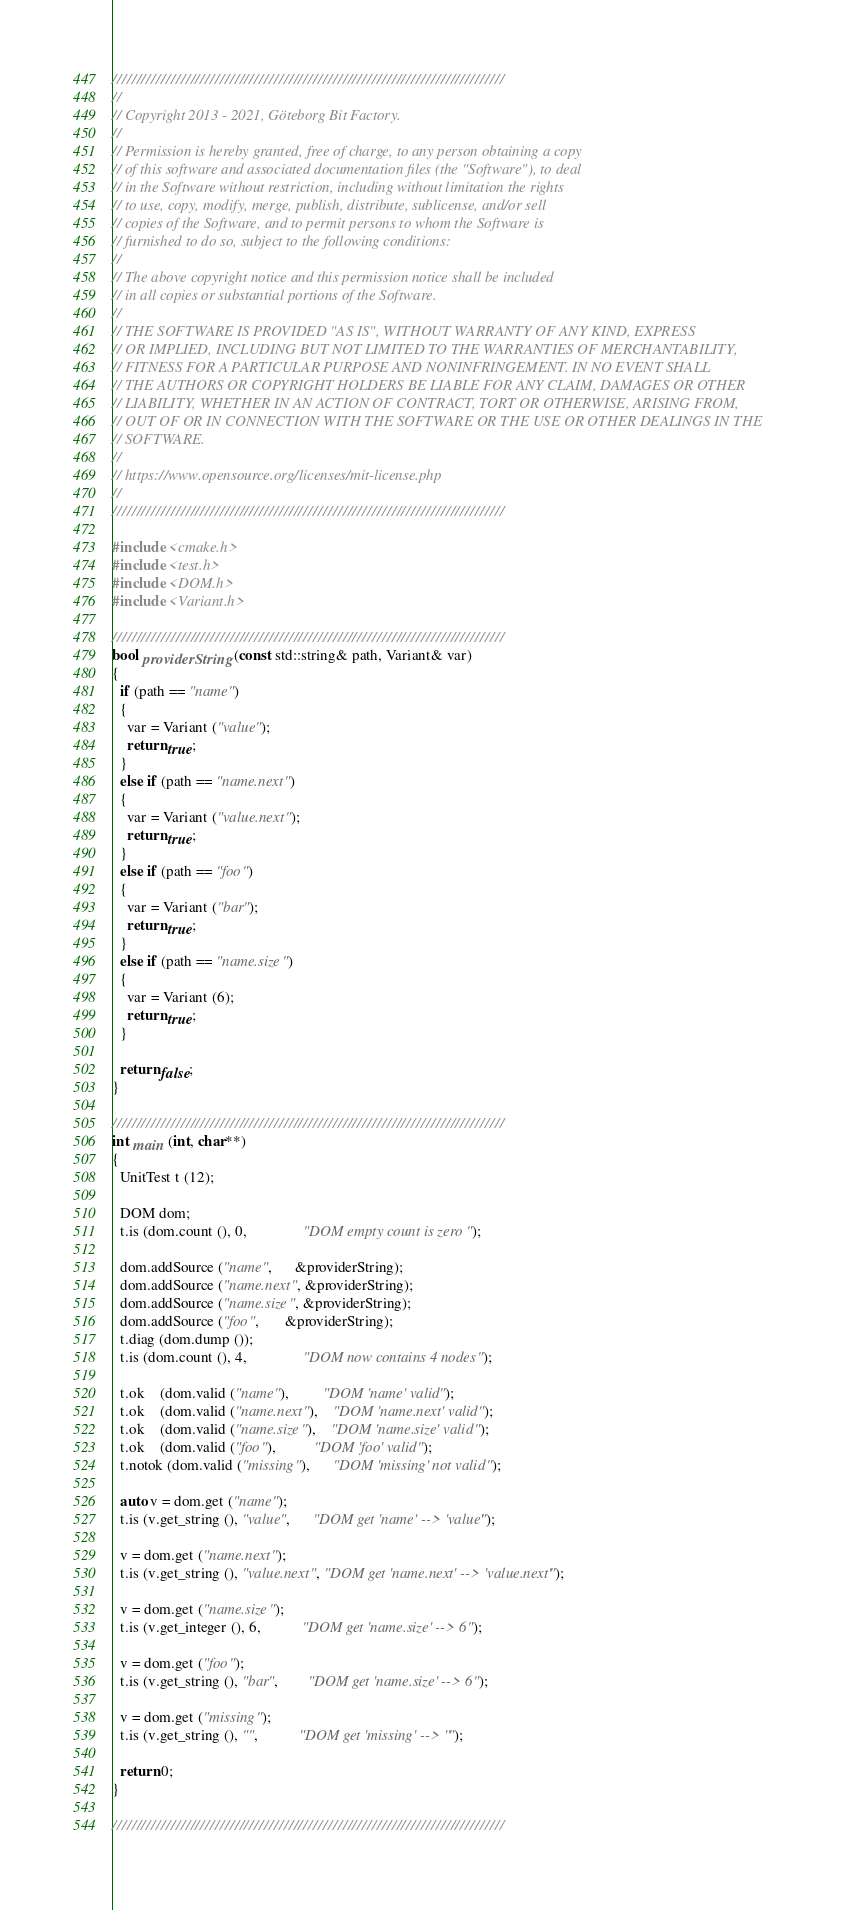Convert code to text. <code><loc_0><loc_0><loc_500><loc_500><_C++_>////////////////////////////////////////////////////////////////////////////////
//
// Copyright 2013 - 2021, Göteborg Bit Factory.
//
// Permission is hereby granted, free of charge, to any person obtaining a copy
// of this software and associated documentation files (the "Software"), to deal
// in the Software without restriction, including without limitation the rights
// to use, copy, modify, merge, publish, distribute, sublicense, and/or sell
// copies of the Software, and to permit persons to whom the Software is
// furnished to do so, subject to the following conditions:
//
// The above copyright notice and this permission notice shall be included
// in all copies or substantial portions of the Software.
//
// THE SOFTWARE IS PROVIDED "AS IS", WITHOUT WARRANTY OF ANY KIND, EXPRESS
// OR IMPLIED, INCLUDING BUT NOT LIMITED TO THE WARRANTIES OF MERCHANTABILITY,
// FITNESS FOR A PARTICULAR PURPOSE AND NONINFRINGEMENT. IN NO EVENT SHALL
// THE AUTHORS OR COPYRIGHT HOLDERS BE LIABLE FOR ANY CLAIM, DAMAGES OR OTHER
// LIABILITY, WHETHER IN AN ACTION OF CONTRACT, TORT OR OTHERWISE, ARISING FROM,
// OUT OF OR IN CONNECTION WITH THE SOFTWARE OR THE USE OR OTHER DEALINGS IN THE
// SOFTWARE.
//
// https://www.opensource.org/licenses/mit-license.php
//
////////////////////////////////////////////////////////////////////////////////

#include <cmake.h>
#include <test.h>
#include <DOM.h>
#include <Variant.h>

////////////////////////////////////////////////////////////////////////////////
bool providerString (const std::string& path, Variant& var)
{
  if (path == "name")
  {
    var = Variant ("value");
    return true;
  }
  else if (path == "name.next")
  {
    var = Variant ("value.next");
    return true;
  }
  else if (path == "foo")
  {
    var = Variant ("bar");
    return true;
  }
  else if (path == "name.size")
  {
    var = Variant (6);
    return true;
  }

  return false;
}

////////////////////////////////////////////////////////////////////////////////
int main (int, char**)
{
  UnitTest t (12);

  DOM dom;
  t.is (dom.count (), 0,               "DOM empty count is zero");

  dom.addSource ("name",      &providerString);
  dom.addSource ("name.next", &providerString);
  dom.addSource ("name.size", &providerString);
  dom.addSource ("foo",       &providerString);
  t.diag (dom.dump ());
  t.is (dom.count (), 4,               "DOM now contains 4 nodes");

  t.ok    (dom.valid ("name"),         "DOM 'name' valid");
  t.ok    (dom.valid ("name.next"),    "DOM 'name.next' valid");
  t.ok    (dom.valid ("name.size"),    "DOM 'name.size' valid");
  t.ok    (dom.valid ("foo"),          "DOM 'foo' valid");
  t.notok (dom.valid ("missing"),      "DOM 'missing' not valid");

  auto v = dom.get ("name");
  t.is (v.get_string (), "value",      "DOM get 'name' --> 'value'");

  v = dom.get ("name.next");
  t.is (v.get_string (), "value.next", "DOM get 'name.next' --> 'value.next'");

  v = dom.get ("name.size");
  t.is (v.get_integer (), 6,           "DOM get 'name.size' --> 6");

  v = dom.get ("foo");
  t.is (v.get_string (), "bar",        "DOM get 'name.size' --> 6");

  v = dom.get ("missing");
  t.is (v.get_string (), "",           "DOM get 'missing' --> ''");

  return 0;
}

////////////////////////////////////////////////////////////////////////////////
</code> 